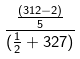<formula> <loc_0><loc_0><loc_500><loc_500>\frac { \frac { ( 3 1 2 - 2 ) } { 5 } } { ( \frac { 1 } { 2 } + 3 2 7 ) }</formula> 